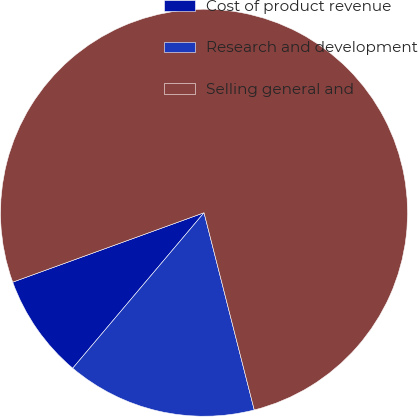Convert chart to OTSL. <chart><loc_0><loc_0><loc_500><loc_500><pie_chart><fcel>Cost of product revenue<fcel>Research and development<fcel>Selling general and<nl><fcel>8.3%<fcel>15.13%<fcel>76.57%<nl></chart> 